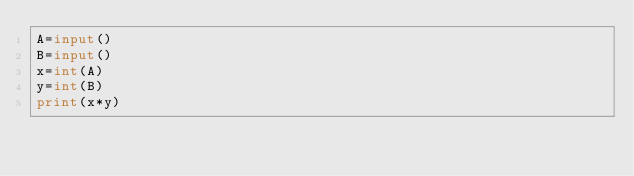Convert code to text. <code><loc_0><loc_0><loc_500><loc_500><_Python_>A=input()
B=input()
x=int(A)
y=int(B)
print(x*y)</code> 